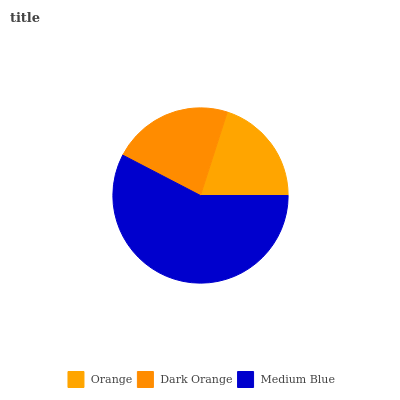Is Orange the minimum?
Answer yes or no. Yes. Is Medium Blue the maximum?
Answer yes or no. Yes. Is Dark Orange the minimum?
Answer yes or no. No. Is Dark Orange the maximum?
Answer yes or no. No. Is Dark Orange greater than Orange?
Answer yes or no. Yes. Is Orange less than Dark Orange?
Answer yes or no. Yes. Is Orange greater than Dark Orange?
Answer yes or no. No. Is Dark Orange less than Orange?
Answer yes or no. No. Is Dark Orange the high median?
Answer yes or no. Yes. Is Dark Orange the low median?
Answer yes or no. Yes. Is Orange the high median?
Answer yes or no. No. Is Orange the low median?
Answer yes or no. No. 